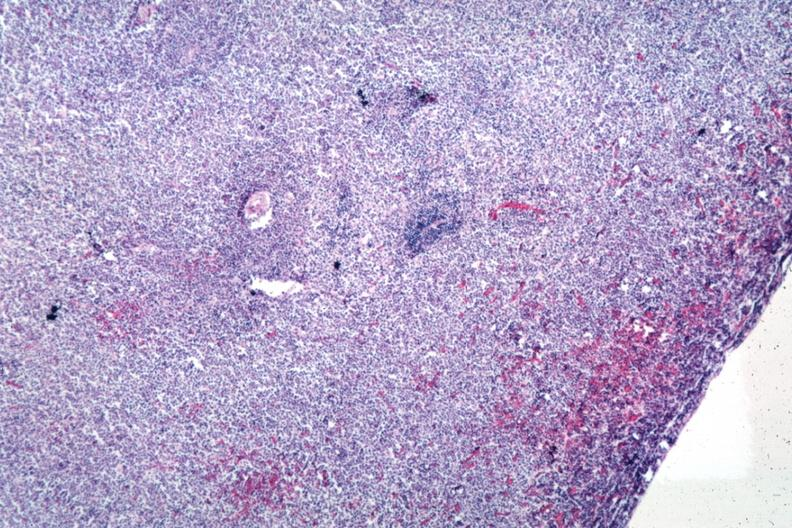what is present?
Answer the question using a single word or phrase. Lymphoblastic lymphoma 